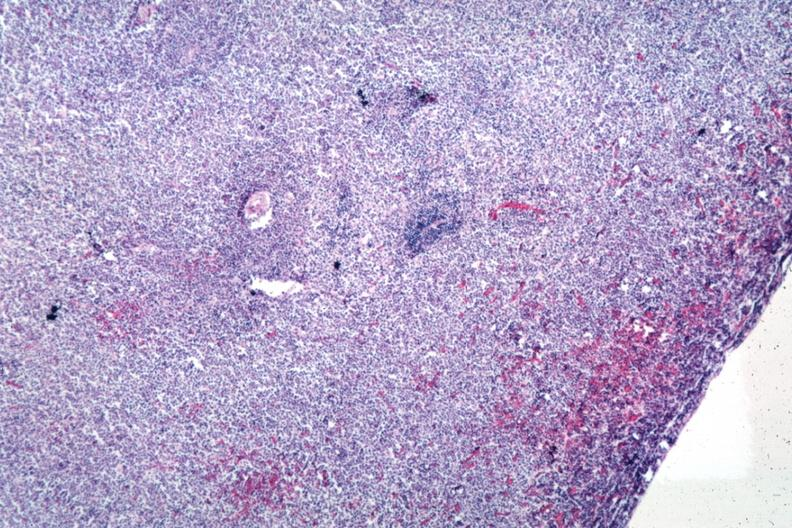what is present?
Answer the question using a single word or phrase. Lymphoblastic lymphoma 